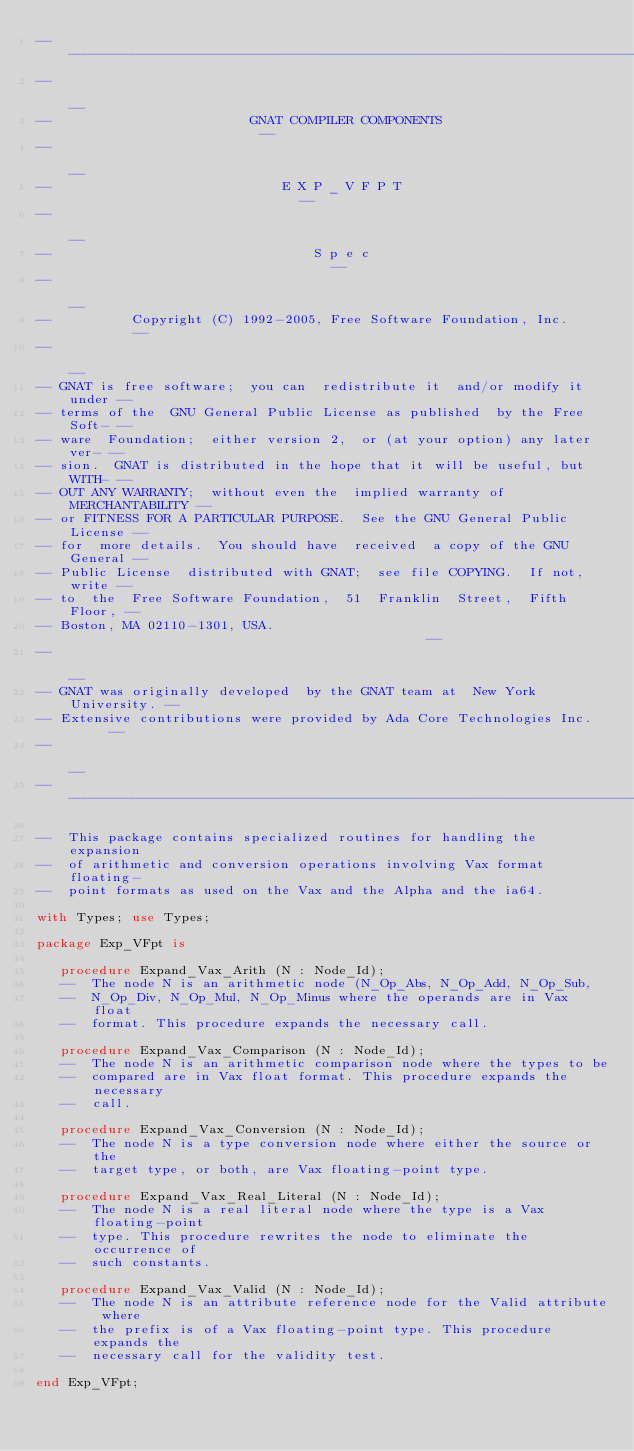Convert code to text. <code><loc_0><loc_0><loc_500><loc_500><_Ada_>------------------------------------------------------------------------------
--                                                                          --
--                         GNAT COMPILER COMPONENTS                         --
--                                                                          --
--                             E X P _ V F P T                              --
--                                                                          --
--                                 S p e c                                  --
--                                                                          --
--          Copyright (C) 1992-2005, Free Software Foundation, Inc.         --
--                                                                          --
-- GNAT is free software;  you can  redistribute it  and/or modify it under --
-- terms of the  GNU General Public License as published  by the Free Soft- --
-- ware  Foundation;  either version 2,  or (at your option) any later ver- --
-- sion.  GNAT is distributed in the hope that it will be useful, but WITH- --
-- OUT ANY WARRANTY;  without even the  implied warranty of MERCHANTABILITY --
-- or FITNESS FOR A PARTICULAR PURPOSE.  See the GNU General Public License --
-- for  more details.  You should have  received  a copy of the GNU General --
-- Public License  distributed with GNAT;  see file COPYING.  If not, write --
-- to  the  Free Software Foundation,  51  Franklin  Street,  Fifth  Floor, --
-- Boston, MA 02110-1301, USA.                                              --
--                                                                          --
-- GNAT was originally developed  by the GNAT team at  New York University. --
-- Extensive contributions were provided by Ada Core Technologies Inc.      --
--                                                                          --
------------------------------------------------------------------------------

--  This package contains specialized routines for handling the expansion
--  of arithmetic and conversion operations involving Vax format floating-
--  point formats as used on the Vax and the Alpha and the ia64.

with Types; use Types;

package Exp_VFpt is

   procedure Expand_Vax_Arith (N : Node_Id);
   --  The node N is an arithmetic node (N_Op_Abs, N_Op_Add, N_Op_Sub,
   --  N_Op_Div, N_Op_Mul, N_Op_Minus where the operands are in Vax float
   --  format. This procedure expands the necessary call.

   procedure Expand_Vax_Comparison (N : Node_Id);
   --  The node N is an arithmetic comparison node where the types to be
   --  compared are in Vax float format. This procedure expands the necessary
   --  call.

   procedure Expand_Vax_Conversion (N : Node_Id);
   --  The node N is a type conversion node where either the source or the
   --  target type, or both, are Vax floating-point type.

   procedure Expand_Vax_Real_Literal (N : Node_Id);
   --  The node N is a real literal node where the type is a Vax floating-point
   --  type. This procedure rewrites the node to eliminate the occurrence of
   --  such constants.

   procedure Expand_Vax_Valid (N : Node_Id);
   --  The node N is an attribute reference node for the Valid attribute where
   --  the prefix is of a Vax floating-point type. This procedure expands the
   --  necessary call for the validity test.

end Exp_VFpt;
</code> 